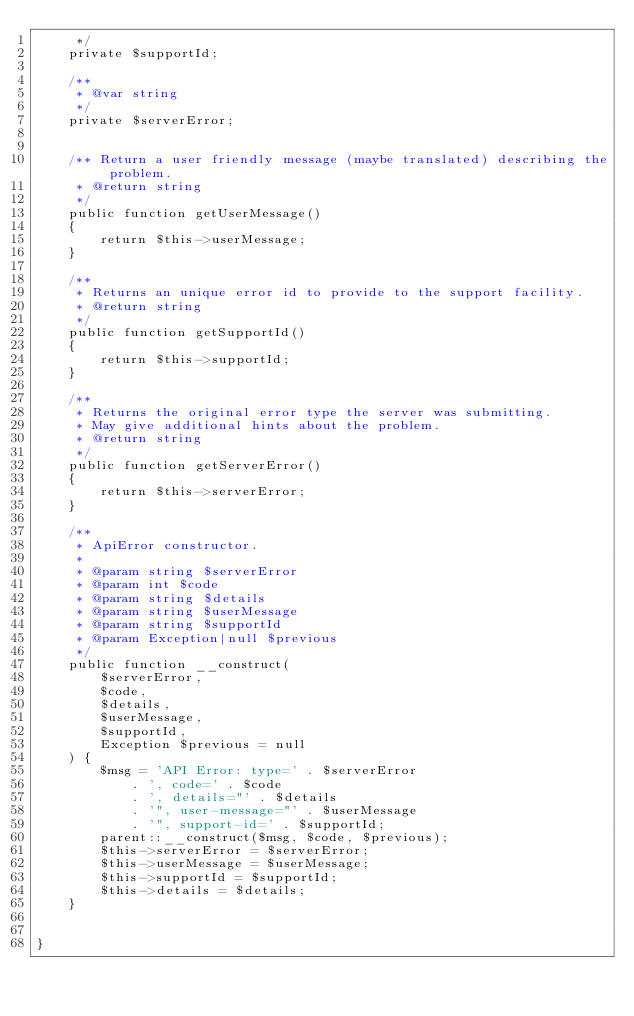<code> <loc_0><loc_0><loc_500><loc_500><_PHP_>     */
    private $supportId;

    /**
     * @var string
     */
    private $serverError;


    /** Return a user friendly message (maybe translated) describing the problem.
     * @return string
     */
    public function getUserMessage()
    {
        return $this->userMessage;
    }

    /**
     * Returns an unique error id to provide to the support facility.
     * @return string
     */
    public function getSupportId()
    {
        return $this->supportId;
    }

    /**
     * Returns the original error type the server was submitting.
     * May give additional hints about the problem.
     * @return string
     */
    public function getServerError()
    {
        return $this->serverError;
    }

    /**
     * ApiError constructor.
     *
     * @param string $serverError
     * @param int $code
     * @param string $details
     * @param string $userMessage
     * @param string $supportId
     * @param Exception|null $previous
     */
    public function __construct(
        $serverError,
        $code,
        $details,
        $userMessage,
        $supportId,
        Exception $previous = null
    ) {
        $msg = 'API Error: type=' . $serverError
            . ', code=' . $code
            . ', details="' . $details
            . '", user-message="' . $userMessage
            . '", support-id=' . $supportId;
        parent::__construct($msg, $code, $previous);
        $this->serverError = $serverError;
        $this->userMessage = $userMessage;
        $this->supportId = $supportId;
        $this->details = $details;
    }


}
</code> 